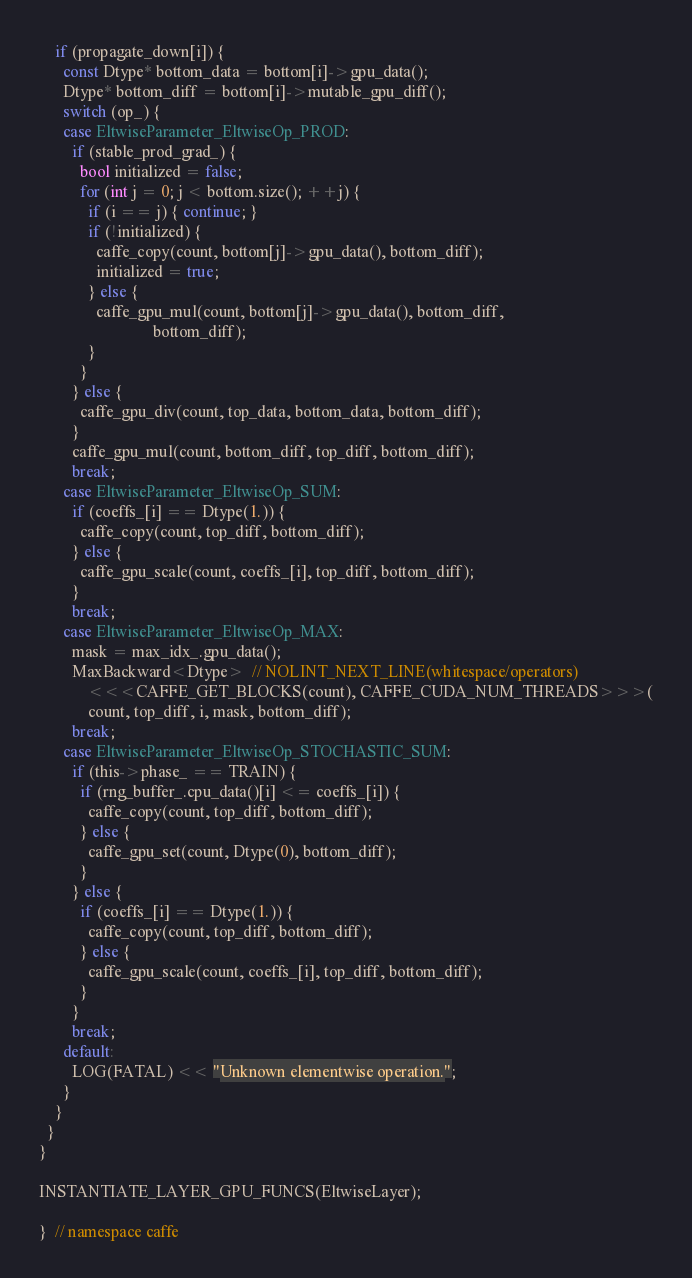Convert code to text. <code><loc_0><loc_0><loc_500><loc_500><_Cuda_>    if (propagate_down[i]) {
      const Dtype* bottom_data = bottom[i]->gpu_data();
      Dtype* bottom_diff = bottom[i]->mutable_gpu_diff();
      switch (op_) {
      case EltwiseParameter_EltwiseOp_PROD:
        if (stable_prod_grad_) {
          bool initialized = false;
          for (int j = 0; j < bottom.size(); ++j) {
            if (i == j) { continue; }
            if (!initialized) {
              caffe_copy(count, bottom[j]->gpu_data(), bottom_diff);
              initialized = true;
            } else {
              caffe_gpu_mul(count, bottom[j]->gpu_data(), bottom_diff,
                            bottom_diff);
            }
          }
        } else {
          caffe_gpu_div(count, top_data, bottom_data, bottom_diff);
        }
        caffe_gpu_mul(count, bottom_diff, top_diff, bottom_diff);
        break;
      case EltwiseParameter_EltwiseOp_SUM:
        if (coeffs_[i] == Dtype(1.)) {
          caffe_copy(count, top_diff, bottom_diff);
        } else {
          caffe_gpu_scale(count, coeffs_[i], top_diff, bottom_diff);
        }
        break;
      case EltwiseParameter_EltwiseOp_MAX:
        mask = max_idx_.gpu_data();
        MaxBackward<Dtype>  // NOLINT_NEXT_LINE(whitespace/operators)
            <<<CAFFE_GET_BLOCKS(count), CAFFE_CUDA_NUM_THREADS>>>(
            count, top_diff, i, mask, bottom_diff);
        break;
      case EltwiseParameter_EltwiseOp_STOCHASTIC_SUM:
        if (this->phase_ == TRAIN) {
          if (rng_buffer_.cpu_data()[i] <= coeffs_[i]) {
            caffe_copy(count, top_diff, bottom_diff);
          } else {
            caffe_gpu_set(count, Dtype(0), bottom_diff);
          }
        } else {
          if (coeffs_[i] == Dtype(1.)) {
            caffe_copy(count, top_diff, bottom_diff);
          } else {
            caffe_gpu_scale(count, coeffs_[i], top_diff, bottom_diff);
          }
        }
        break;
      default:
        LOG(FATAL) << "Unknown elementwise operation.";
      }
    }
  }
}

INSTANTIATE_LAYER_GPU_FUNCS(EltwiseLayer);

}  // namespace caffe
</code> 